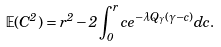Convert formula to latex. <formula><loc_0><loc_0><loc_500><loc_500>\mathbb { E } ( C ^ { 2 } ) = r ^ { 2 } - 2 \int _ { 0 } ^ { r } c e ^ { - \lambda Q _ { \gamma } ( \gamma - c ) } d c .</formula> 